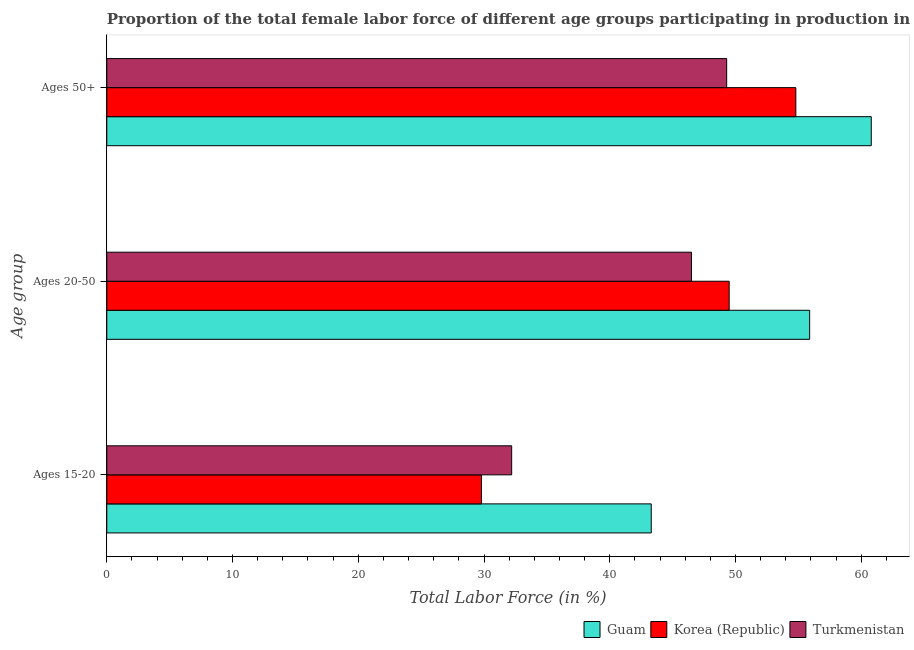How many different coloured bars are there?
Offer a terse response. 3. Are the number of bars per tick equal to the number of legend labels?
Your response must be concise. Yes. How many bars are there on the 3rd tick from the top?
Your answer should be very brief. 3. How many bars are there on the 3rd tick from the bottom?
Give a very brief answer. 3. What is the label of the 3rd group of bars from the top?
Make the answer very short. Ages 15-20. What is the percentage of female labor force above age 50 in Turkmenistan?
Provide a short and direct response. 49.3. Across all countries, what is the maximum percentage of female labor force within the age group 20-50?
Your response must be concise. 55.9. Across all countries, what is the minimum percentage of female labor force within the age group 15-20?
Offer a terse response. 29.8. In which country was the percentage of female labor force above age 50 maximum?
Offer a terse response. Guam. In which country was the percentage of female labor force within the age group 20-50 minimum?
Keep it short and to the point. Turkmenistan. What is the total percentage of female labor force above age 50 in the graph?
Provide a short and direct response. 164.9. What is the difference between the percentage of female labor force within the age group 20-50 in Turkmenistan and that in Guam?
Your answer should be very brief. -9.4. What is the difference between the percentage of female labor force within the age group 15-20 in Turkmenistan and the percentage of female labor force within the age group 20-50 in Guam?
Your answer should be very brief. -23.7. What is the average percentage of female labor force within the age group 15-20 per country?
Provide a short and direct response. 35.1. What is the difference between the percentage of female labor force within the age group 15-20 and percentage of female labor force above age 50 in Guam?
Offer a very short reply. -17.5. What is the ratio of the percentage of female labor force within the age group 20-50 in Turkmenistan to that in Korea (Republic)?
Keep it short and to the point. 0.94. What is the difference between the highest and the lowest percentage of female labor force within the age group 20-50?
Ensure brevity in your answer.  9.4. In how many countries, is the percentage of female labor force within the age group 15-20 greater than the average percentage of female labor force within the age group 15-20 taken over all countries?
Offer a terse response. 1. What does the 1st bar from the top in Ages 20-50 represents?
Your answer should be compact. Turkmenistan. What does the 2nd bar from the bottom in Ages 20-50 represents?
Offer a terse response. Korea (Republic). Is it the case that in every country, the sum of the percentage of female labor force within the age group 15-20 and percentage of female labor force within the age group 20-50 is greater than the percentage of female labor force above age 50?
Ensure brevity in your answer.  Yes. How many bars are there?
Give a very brief answer. 9. Are all the bars in the graph horizontal?
Give a very brief answer. Yes. Does the graph contain any zero values?
Give a very brief answer. No. How many legend labels are there?
Give a very brief answer. 3. How are the legend labels stacked?
Offer a very short reply. Horizontal. What is the title of the graph?
Your response must be concise. Proportion of the total female labor force of different age groups participating in production in 2011. What is the label or title of the X-axis?
Offer a terse response. Total Labor Force (in %). What is the label or title of the Y-axis?
Your response must be concise. Age group. What is the Total Labor Force (in %) of Guam in Ages 15-20?
Your response must be concise. 43.3. What is the Total Labor Force (in %) of Korea (Republic) in Ages 15-20?
Provide a succinct answer. 29.8. What is the Total Labor Force (in %) in Turkmenistan in Ages 15-20?
Ensure brevity in your answer.  32.2. What is the Total Labor Force (in %) of Guam in Ages 20-50?
Your answer should be very brief. 55.9. What is the Total Labor Force (in %) in Korea (Republic) in Ages 20-50?
Ensure brevity in your answer.  49.5. What is the Total Labor Force (in %) in Turkmenistan in Ages 20-50?
Offer a very short reply. 46.5. What is the Total Labor Force (in %) in Guam in Ages 50+?
Offer a terse response. 60.8. What is the Total Labor Force (in %) in Korea (Republic) in Ages 50+?
Give a very brief answer. 54.8. What is the Total Labor Force (in %) in Turkmenistan in Ages 50+?
Give a very brief answer. 49.3. Across all Age group, what is the maximum Total Labor Force (in %) of Guam?
Provide a short and direct response. 60.8. Across all Age group, what is the maximum Total Labor Force (in %) in Korea (Republic)?
Offer a very short reply. 54.8. Across all Age group, what is the maximum Total Labor Force (in %) in Turkmenistan?
Ensure brevity in your answer.  49.3. Across all Age group, what is the minimum Total Labor Force (in %) of Guam?
Provide a short and direct response. 43.3. Across all Age group, what is the minimum Total Labor Force (in %) of Korea (Republic)?
Keep it short and to the point. 29.8. Across all Age group, what is the minimum Total Labor Force (in %) of Turkmenistan?
Provide a short and direct response. 32.2. What is the total Total Labor Force (in %) in Guam in the graph?
Provide a succinct answer. 160. What is the total Total Labor Force (in %) of Korea (Republic) in the graph?
Make the answer very short. 134.1. What is the total Total Labor Force (in %) of Turkmenistan in the graph?
Provide a short and direct response. 128. What is the difference between the Total Labor Force (in %) in Korea (Republic) in Ages 15-20 and that in Ages 20-50?
Keep it short and to the point. -19.7. What is the difference between the Total Labor Force (in %) of Turkmenistan in Ages 15-20 and that in Ages 20-50?
Provide a short and direct response. -14.3. What is the difference between the Total Labor Force (in %) in Guam in Ages 15-20 and that in Ages 50+?
Ensure brevity in your answer.  -17.5. What is the difference between the Total Labor Force (in %) in Turkmenistan in Ages 15-20 and that in Ages 50+?
Provide a succinct answer. -17.1. What is the difference between the Total Labor Force (in %) of Guam in Ages 20-50 and that in Ages 50+?
Provide a succinct answer. -4.9. What is the difference between the Total Labor Force (in %) of Turkmenistan in Ages 20-50 and that in Ages 50+?
Your answer should be compact. -2.8. What is the difference between the Total Labor Force (in %) of Korea (Republic) in Ages 15-20 and the Total Labor Force (in %) of Turkmenistan in Ages 20-50?
Your response must be concise. -16.7. What is the difference between the Total Labor Force (in %) of Guam in Ages 15-20 and the Total Labor Force (in %) of Korea (Republic) in Ages 50+?
Give a very brief answer. -11.5. What is the difference between the Total Labor Force (in %) in Korea (Republic) in Ages 15-20 and the Total Labor Force (in %) in Turkmenistan in Ages 50+?
Your answer should be very brief. -19.5. What is the difference between the Total Labor Force (in %) of Guam in Ages 20-50 and the Total Labor Force (in %) of Korea (Republic) in Ages 50+?
Provide a succinct answer. 1.1. What is the average Total Labor Force (in %) of Guam per Age group?
Your answer should be compact. 53.33. What is the average Total Labor Force (in %) in Korea (Republic) per Age group?
Provide a short and direct response. 44.7. What is the average Total Labor Force (in %) of Turkmenistan per Age group?
Offer a very short reply. 42.67. What is the difference between the Total Labor Force (in %) of Guam and Total Labor Force (in %) of Turkmenistan in Ages 20-50?
Offer a very short reply. 9.4. What is the difference between the Total Labor Force (in %) in Korea (Republic) and Total Labor Force (in %) in Turkmenistan in Ages 20-50?
Offer a terse response. 3. What is the difference between the Total Labor Force (in %) in Guam and Total Labor Force (in %) in Turkmenistan in Ages 50+?
Give a very brief answer. 11.5. What is the ratio of the Total Labor Force (in %) in Guam in Ages 15-20 to that in Ages 20-50?
Your answer should be compact. 0.77. What is the ratio of the Total Labor Force (in %) in Korea (Republic) in Ages 15-20 to that in Ages 20-50?
Offer a terse response. 0.6. What is the ratio of the Total Labor Force (in %) in Turkmenistan in Ages 15-20 to that in Ages 20-50?
Offer a very short reply. 0.69. What is the ratio of the Total Labor Force (in %) of Guam in Ages 15-20 to that in Ages 50+?
Offer a very short reply. 0.71. What is the ratio of the Total Labor Force (in %) in Korea (Republic) in Ages 15-20 to that in Ages 50+?
Ensure brevity in your answer.  0.54. What is the ratio of the Total Labor Force (in %) of Turkmenistan in Ages 15-20 to that in Ages 50+?
Give a very brief answer. 0.65. What is the ratio of the Total Labor Force (in %) of Guam in Ages 20-50 to that in Ages 50+?
Provide a short and direct response. 0.92. What is the ratio of the Total Labor Force (in %) of Korea (Republic) in Ages 20-50 to that in Ages 50+?
Make the answer very short. 0.9. What is the ratio of the Total Labor Force (in %) in Turkmenistan in Ages 20-50 to that in Ages 50+?
Your answer should be compact. 0.94. What is the difference between the highest and the second highest Total Labor Force (in %) in Guam?
Your response must be concise. 4.9. What is the difference between the highest and the second highest Total Labor Force (in %) of Turkmenistan?
Keep it short and to the point. 2.8. What is the difference between the highest and the lowest Total Labor Force (in %) of Guam?
Offer a terse response. 17.5. What is the difference between the highest and the lowest Total Labor Force (in %) of Korea (Republic)?
Provide a short and direct response. 25. What is the difference between the highest and the lowest Total Labor Force (in %) in Turkmenistan?
Your answer should be compact. 17.1. 